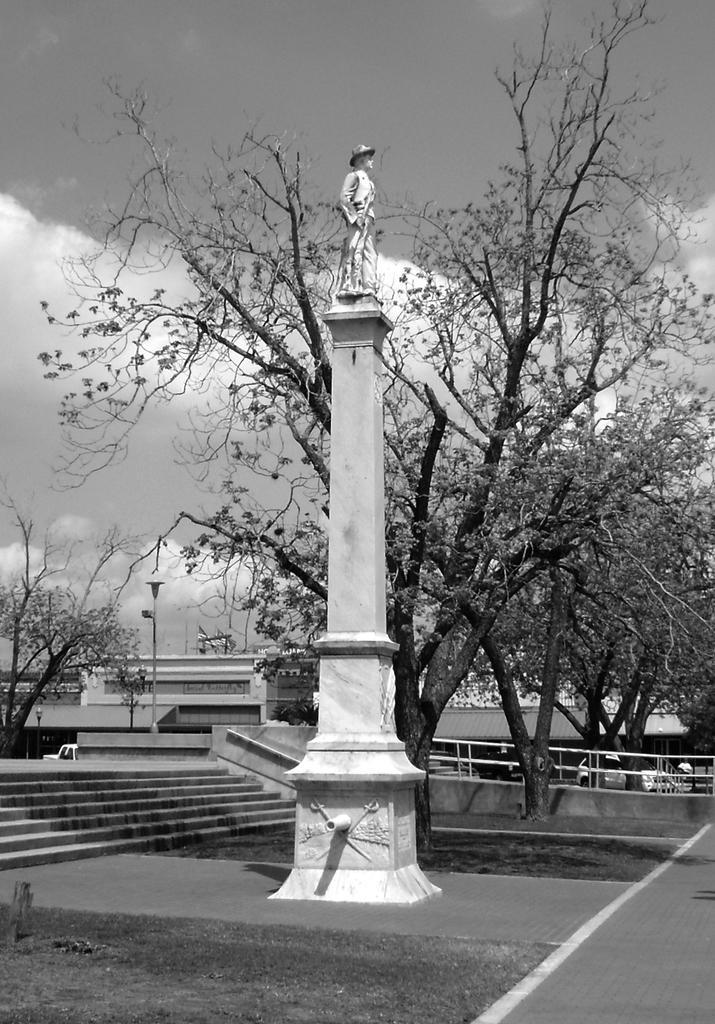Could you give a brief overview of what you see in this image? In this picture there is a statue on the pillar, beside that we can see the stairs. On the right we can see the trees and fencing. In the background we can see the bridge. At the top we can see sky and clouds. Behind the fencing we can see some cars which is found near to the pole. 